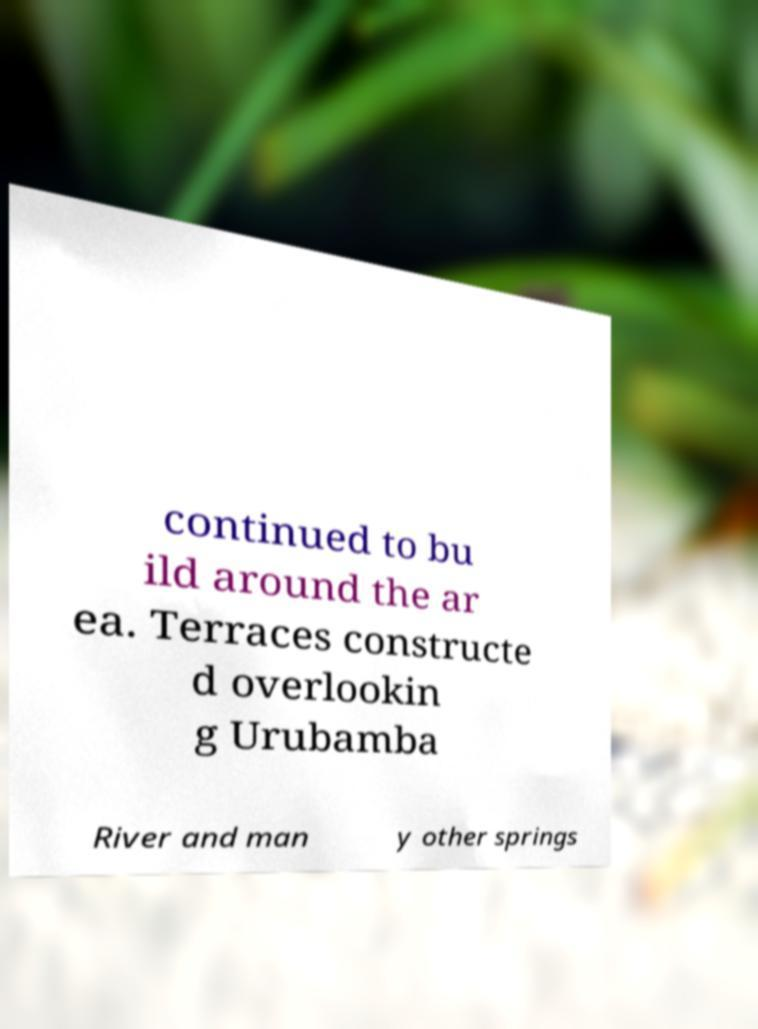There's text embedded in this image that I need extracted. Can you transcribe it verbatim? continued to bu ild around the ar ea. Terraces constructe d overlookin g Urubamba River and man y other springs 